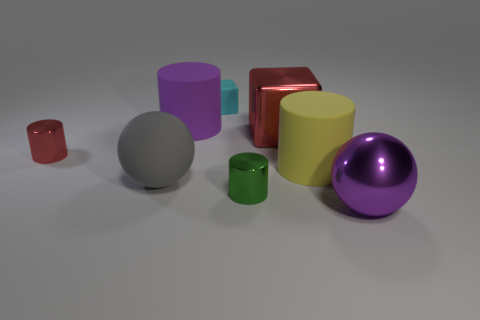What number of purple shiny cubes are there?
Give a very brief answer. 0. Are there fewer gray matte balls that are right of the big purple metallic ball than big purple objects that are on the left side of the tiny cyan block?
Make the answer very short. Yes. Are there fewer purple objects behind the small block than large purple things?
Give a very brief answer. Yes. What is the tiny cylinder that is on the left side of the big thing that is behind the large metallic thing left of the large purple shiny ball made of?
Ensure brevity in your answer.  Metal. How many objects are large matte cylinders that are right of the metal cube or big rubber cylinders that are in front of the red cylinder?
Give a very brief answer. 1. What material is the other object that is the same shape as the large gray matte object?
Your answer should be very brief. Metal. What number of rubber objects are large things or small objects?
Your answer should be compact. 4. There is a gray object that is made of the same material as the small cyan thing; what is its shape?
Your answer should be very brief. Sphere. What number of purple things are the same shape as the big gray object?
Offer a terse response. 1. Does the large purple object in front of the gray thing have the same shape as the big thing that is left of the large purple matte cylinder?
Provide a succinct answer. Yes. 